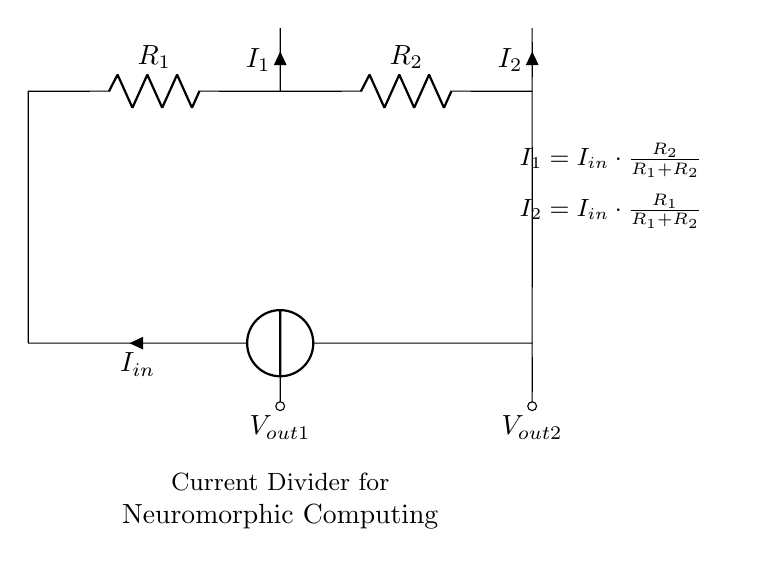What are the resistors in the circuit? The circuit contains two resistors labeled as R1 and R2. They are essential for dividing the input current.
Answer: R1, R2 What is the input current represented in the circuit? The input current is labeled as Iin. It flows into the junction of the two resistors.
Answer: Iin What are the output currents in this circuit? The output currents are labeled I1 and I2. They represent the currents flowing through R1 and R2 respectively after the input current is divided.
Answer: I1, I2 How is current I1 calculated? Current I1 can be calculated using the formula I1 = Iin * (R2 / (R1 + R2)), which represents the current divided based on the values of the resistors R1 and R2.
Answer: Iin * (R2 / (R1 + R2)) How is current I2 calculated? Current I2 is determined using I2 = Iin * (R1 / (R1 + R2)), based on the division of the input current by the values of R1 and R2.
Answer: Iin * (R1 / (R1 + R2)) What type of circuit is represented? The circuit is a current divider, used for distributing input current into multiple paths through different resistors.
Answer: Current divider 